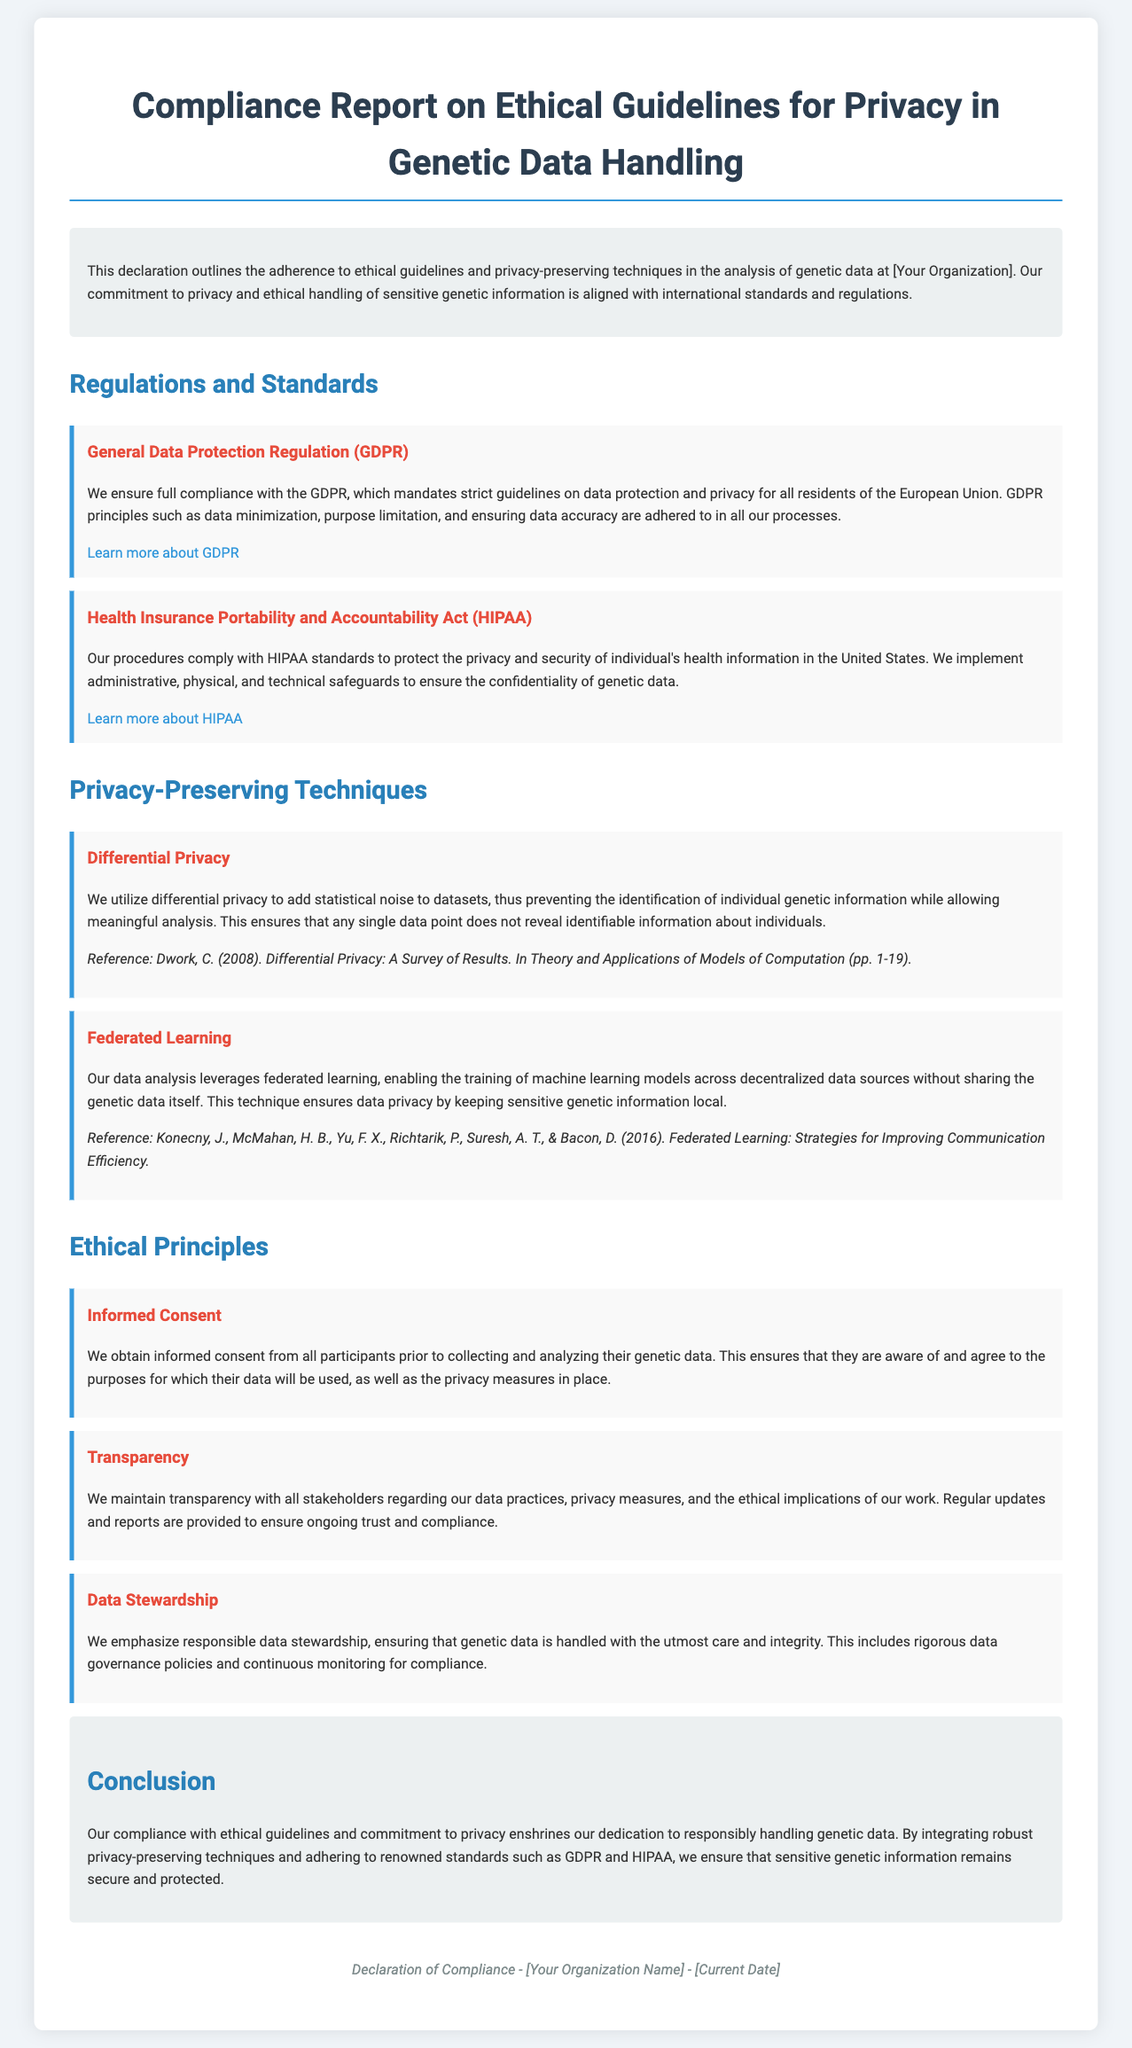What is the title of the document? The title of the document is typically presented prominently at the top.
Answer: Compliance Report on Ethical Guidelines for Privacy in Genetic Data Handling Which regulation focuses on data protection and privacy for EU residents? The document lists regulations that apply to genetic data, one of which specifically addresses EU privacy.
Answer: General Data Protection Regulation (GDPR) What principle ensures participants understand data usage? The document outlines ethical principles, one of which clearly addresses how consent is obtained.
Answer: Informed Consent What technique adds statistical noise to datasets? The document mentions a privacy-preserving technique specifically designed to prevent identifiable information disclosure.
Answer: Differential Privacy How many privacy-preserving techniques are mentioned? To answer this, count the distinct techniques listed in the relevant section of the document.
Answer: Two Which act is focused on protecting health information in the United States? The document references a specific act that protects individual's health information.
Answer: Health Insurance Portability and Accountability Act (HIPAA) What is the primary focus of the compliance report? The document's introduction states the commitment it addresses.
Answer: Ethical guidelines and privacy-preserving techniques When was the compliance declaration made? The footer typically contains the current date of the declaration.
Answer: [Current Date] 